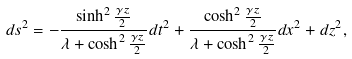<formula> <loc_0><loc_0><loc_500><loc_500>d s ^ { 2 } = - \frac { \sinh ^ { 2 } \frac { \gamma z } { 2 } } { \lambda + \cosh ^ { 2 } \frac { \gamma z } { 2 } } d t ^ { 2 } + \frac { \cosh ^ { 2 } \frac { \gamma z } { 2 } } { \lambda + \cosh ^ { 2 } \frac { \gamma z } { 2 } } d x ^ { 2 } + d z ^ { 2 } ,</formula> 